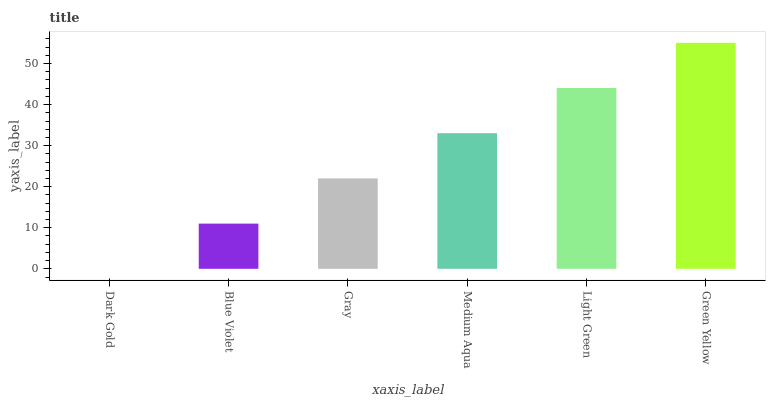Is Dark Gold the minimum?
Answer yes or no. Yes. Is Green Yellow the maximum?
Answer yes or no. Yes. Is Blue Violet the minimum?
Answer yes or no. No. Is Blue Violet the maximum?
Answer yes or no. No. Is Blue Violet greater than Dark Gold?
Answer yes or no. Yes. Is Dark Gold less than Blue Violet?
Answer yes or no. Yes. Is Dark Gold greater than Blue Violet?
Answer yes or no. No. Is Blue Violet less than Dark Gold?
Answer yes or no. No. Is Medium Aqua the high median?
Answer yes or no. Yes. Is Gray the low median?
Answer yes or no. Yes. Is Gray the high median?
Answer yes or no. No. Is Dark Gold the low median?
Answer yes or no. No. 